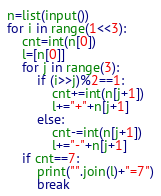Convert code to text. <code><loc_0><loc_0><loc_500><loc_500><_Python_>n=list(input())
for i in range(1<<3):
    cnt=int(n[0])
    l=[n[0]]
    for j in range(3):
        if (i>>j)%2==1:
            cnt+=int(n[j+1])
            l+="+"+n[j+1]
        else:
            cnt-=int(n[j+1])
            l+="-"+n[j+1]
    if cnt==7:
        print("".join(l)+"=7")
        break</code> 